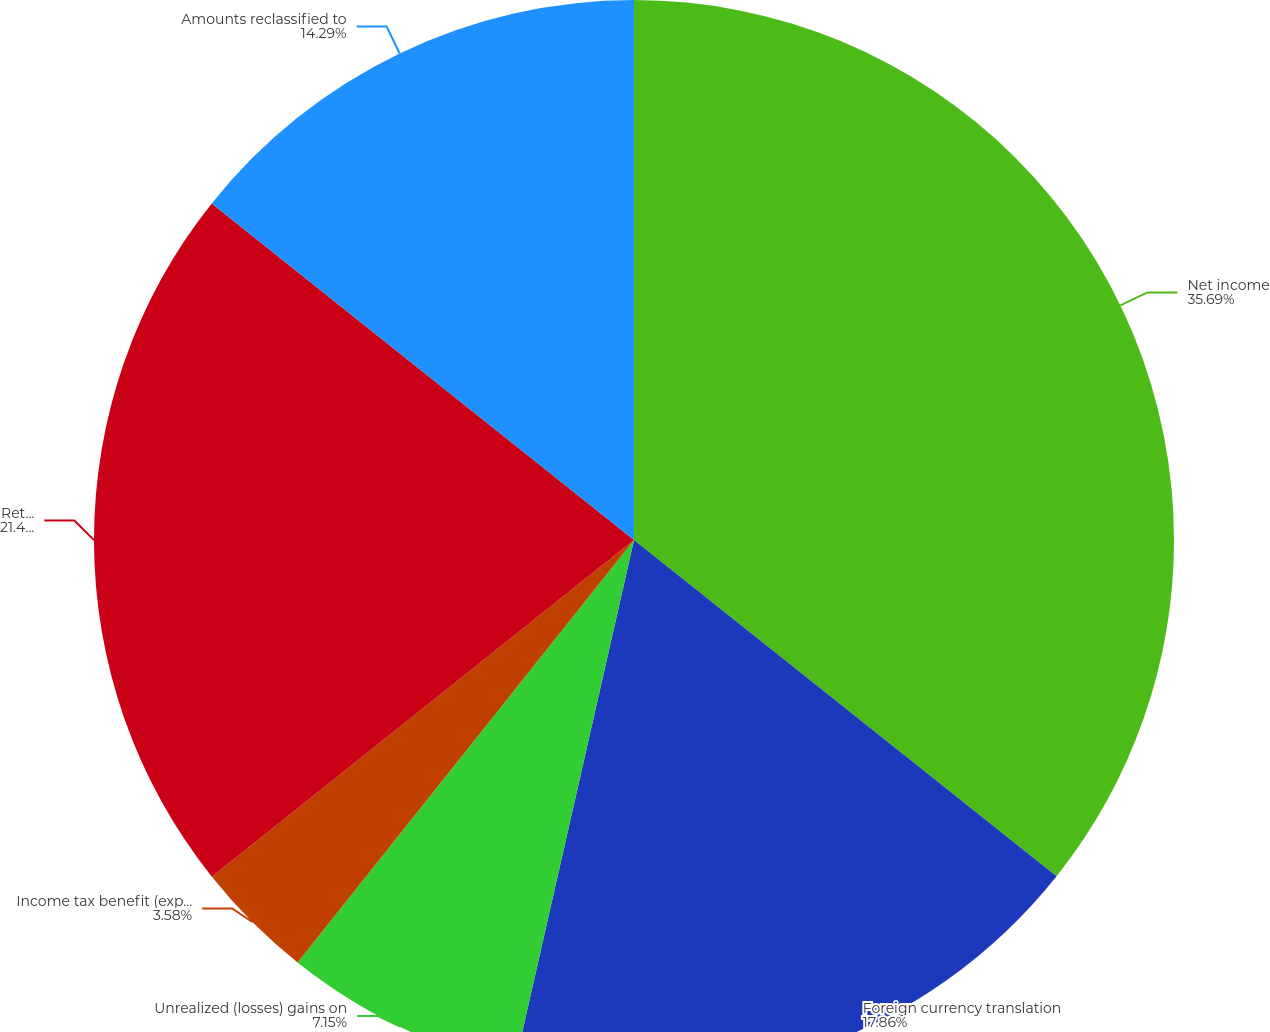Convert chart. <chart><loc_0><loc_0><loc_500><loc_500><pie_chart><fcel>Net income<fcel>Foreign currency translation<fcel>Unrealized (losses) gains on<fcel>Income tax benefit (expense)<fcel>Retirement liability<fcel>Amounts reclassified to<nl><fcel>35.7%<fcel>17.86%<fcel>7.15%<fcel>3.58%<fcel>21.43%<fcel>14.29%<nl></chart> 